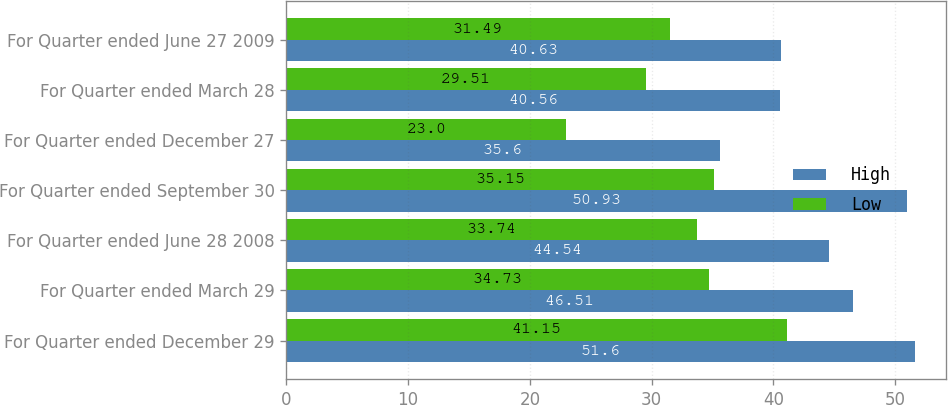Convert chart. <chart><loc_0><loc_0><loc_500><loc_500><stacked_bar_chart><ecel><fcel>For Quarter ended December 29<fcel>For Quarter ended March 29<fcel>For Quarter ended June 28 2008<fcel>For Quarter ended September 30<fcel>For Quarter ended December 27<fcel>For Quarter ended March 28<fcel>For Quarter ended June 27 2009<nl><fcel>High<fcel>51.6<fcel>46.51<fcel>44.54<fcel>50.93<fcel>35.6<fcel>40.56<fcel>40.63<nl><fcel>Low<fcel>41.15<fcel>34.73<fcel>33.74<fcel>35.15<fcel>23<fcel>29.51<fcel>31.49<nl></chart> 